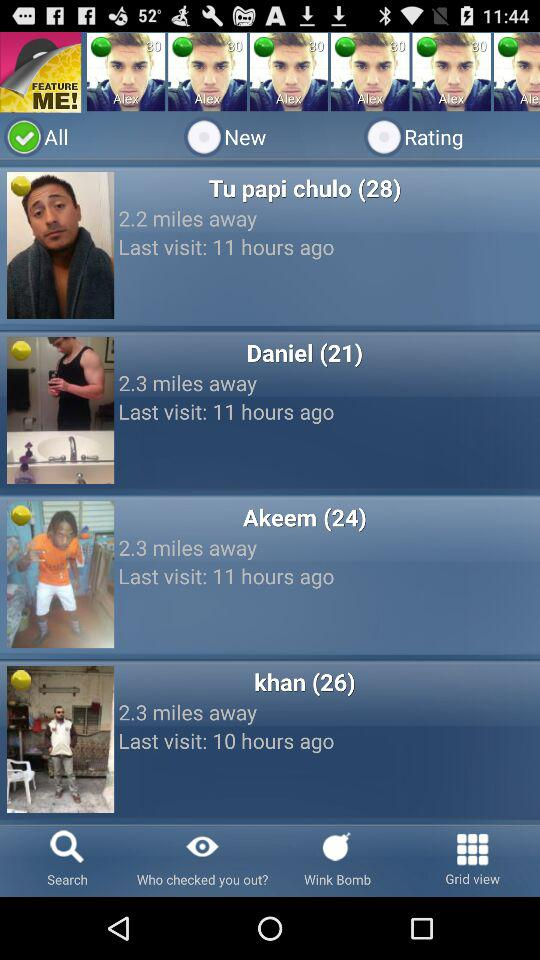When was Akeem's most recent visit? Akeem's most recent visit was 11 hours ago. 